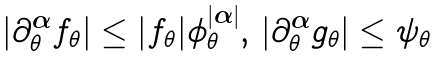Convert formula to latex. <formula><loc_0><loc_0><loc_500><loc_500>\left | \partial _ { \theta } ^ { \boldsymbol \alpha } f _ { \theta } \right | \leq | f _ { \theta } | \phi _ { \theta } ^ { | \boldsymbol \alpha | } , \, \left | \partial _ { \theta } ^ { \boldsymbol \alpha } g _ { \theta } \right | \leq \psi _ { \theta }</formula> 